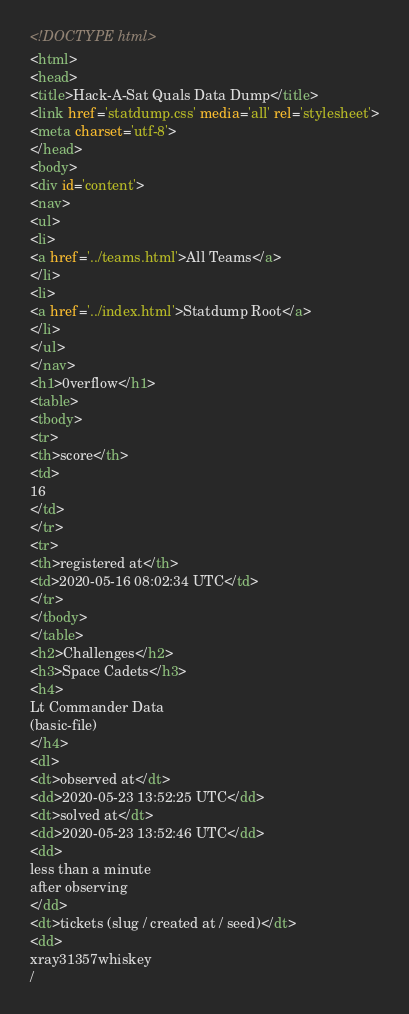Convert code to text. <code><loc_0><loc_0><loc_500><loc_500><_HTML_><!DOCTYPE html>
<html>
<head>
<title>Hack-A-Sat Quals Data Dump</title>
<link href='statdump.css' media='all' rel='stylesheet'>
<meta charset='utf-8'>
</head>
<body>
<div id='content'>
<nav>
<ul>
<li>
<a href='../teams.html'>All Teams</a>
</li>
<li>
<a href='../index.html'>Statdump Root</a>
</li>
</ul>
</nav>
<h1>0verflow</h1>
<table>
<tbody>
<tr>
<th>score</th>
<td>
16
</td>
</tr>
<tr>
<th>registered at</th>
<td>2020-05-16 08:02:34 UTC</td>
</tr>
</tbody>
</table>
<h2>Challenges</h2>
<h3>Space Cadets</h3>
<h4>
Lt Commander Data
(basic-file)
</h4>
<dl>
<dt>observed at</dt>
<dd>2020-05-23 13:52:25 UTC</dd>
<dt>solved at</dt>
<dd>2020-05-23 13:52:46 UTC</dd>
<dd>
less than a minute
after observing
</dd>
<dt>tickets (slug / created at / seed)</dt>
<dd>
xray31357whiskey
/</code> 